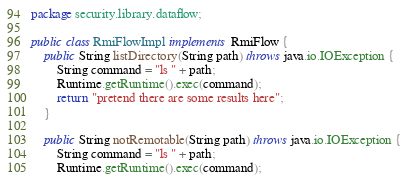<code> <loc_0><loc_0><loc_500><loc_500><_Java_>package security.library.dataflow;

public class RmiFlowImpl implements RmiFlow {
	public String listDirectory(String path) throws java.io.IOException {
		String command = "ls " + path;
		Runtime.getRuntime().exec(command);
		return "pretend there are some results here";
	}

	public String notRemotable(String path) throws java.io.IOException {
		String command = "ls " + path;
		Runtime.getRuntime().exec(command);</code> 